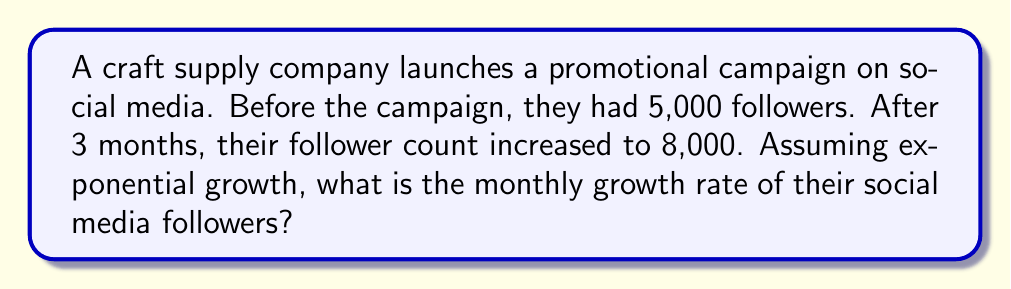Could you help me with this problem? To find the exponential growth rate, we can use the exponential growth formula:

$$A = P(1 + r)^t$$

Where:
$A$ = Final amount (8,000 followers)
$P$ = Initial amount (5,000 followers)
$r$ = Monthly growth rate (what we're solving for)
$t$ = Time in months (3 months)

Let's solve this step-by-step:

1) Substitute the known values into the formula:
   $$8000 = 5000(1 + r)^3$$

2) Divide both sides by 5000:
   $$\frac{8000}{5000} = (1 + r)^3$$

3) Simplify:
   $$1.6 = (1 + r)^3$$

4) Take the cube root of both sides:
   $$\sqrt[3]{1.6} = 1 + r$$

5) Subtract 1 from both sides:
   $$\sqrt[3]{1.6} - 1 = r$$

6) Calculate the result:
   $$r \approx 0.1697 \text{ or } 16.97\%$$

Therefore, the monthly growth rate is approximately 16.97%.
Answer: 16.97% 